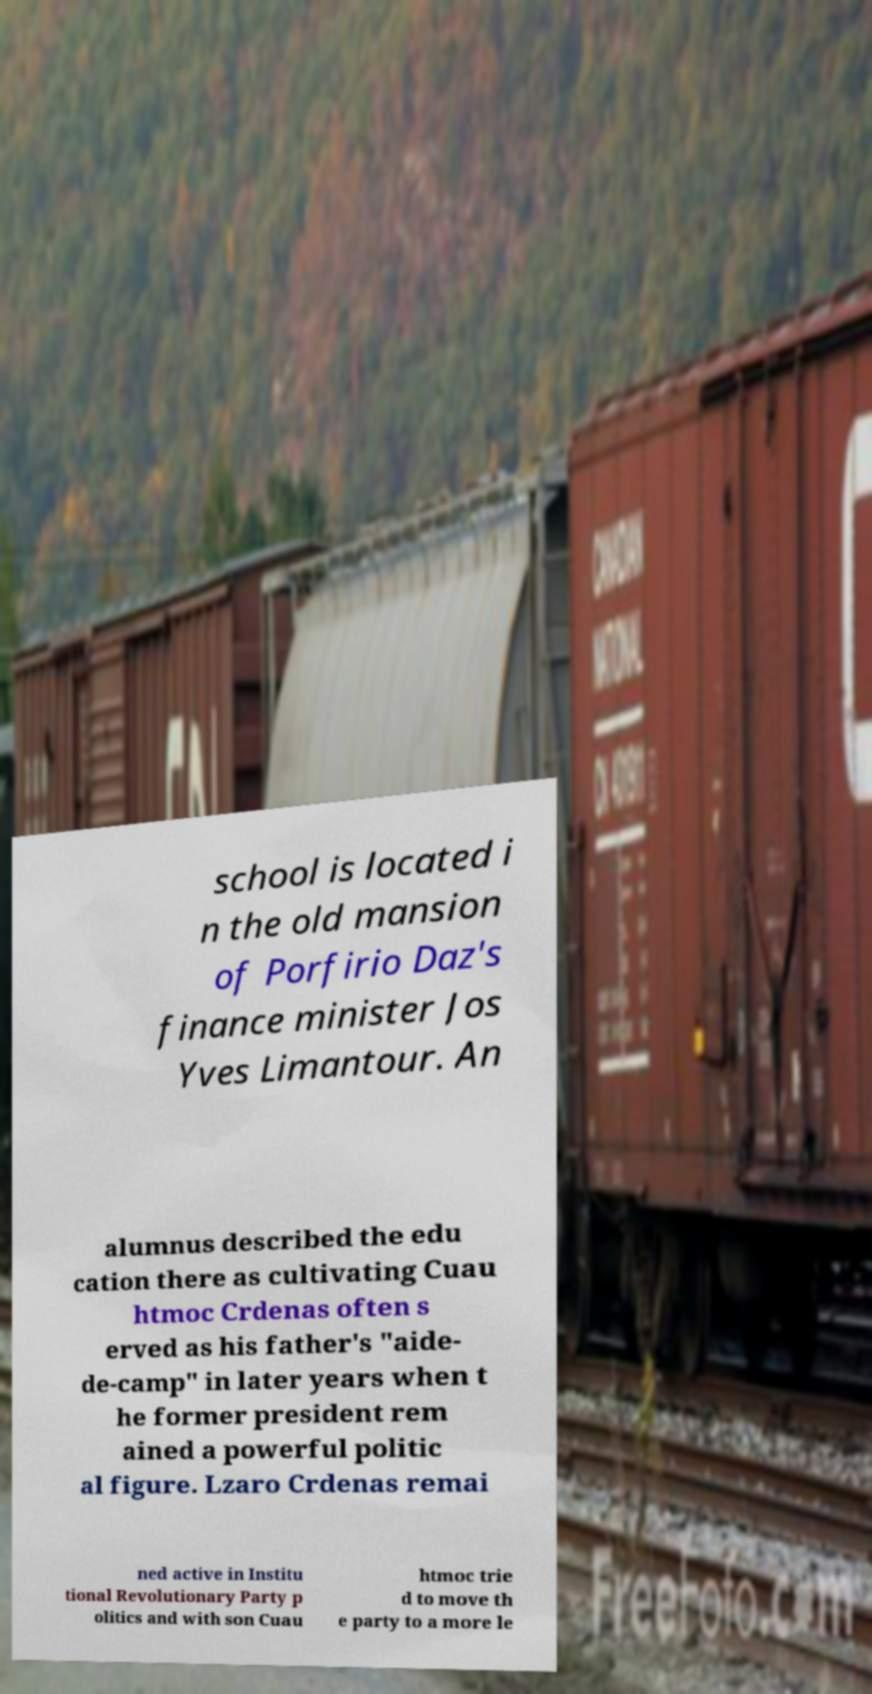Can you accurately transcribe the text from the provided image for me? school is located i n the old mansion of Porfirio Daz's finance minister Jos Yves Limantour. An alumnus described the edu cation there as cultivating Cuau htmoc Crdenas often s erved as his father's "aide- de-camp" in later years when t he former president rem ained a powerful politic al figure. Lzaro Crdenas remai ned active in Institu tional Revolutionary Party p olitics and with son Cuau htmoc trie d to move th e party to a more le 